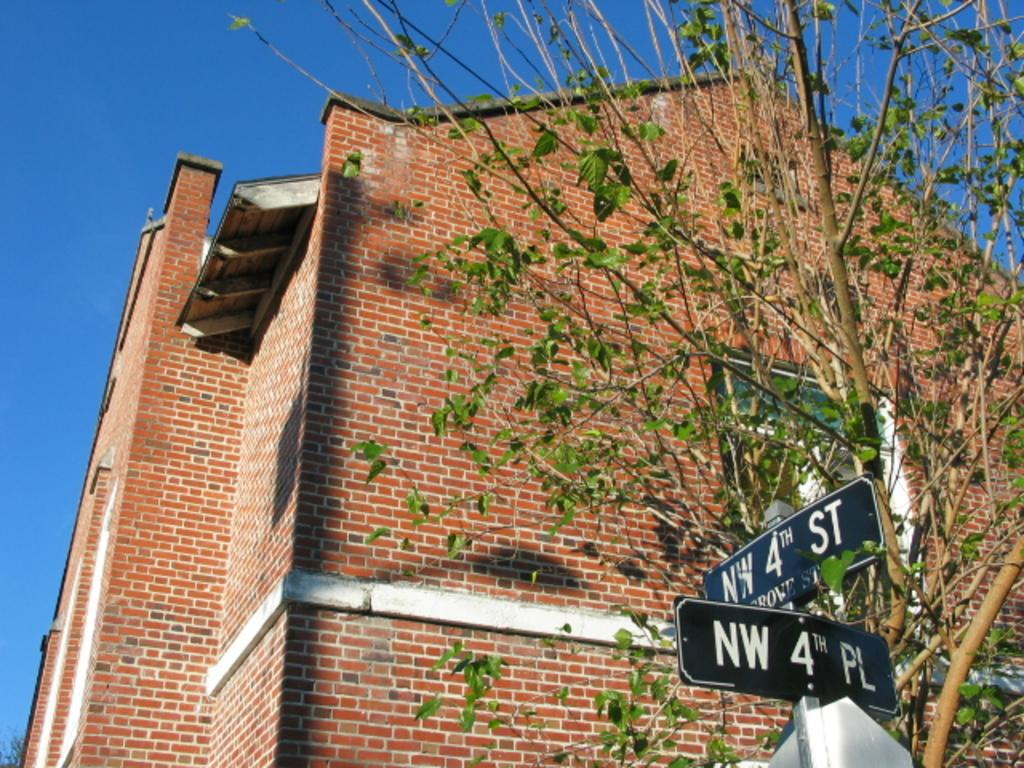<image>
Give a short and clear explanation of the subsequent image. Two street signs designate the intersection of NW 4th Street and NW 4th Place. 